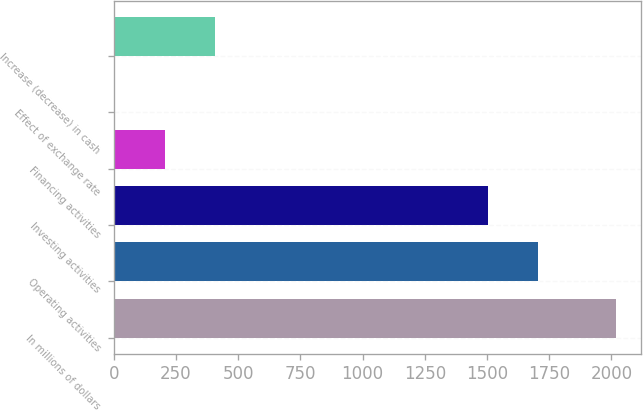<chart> <loc_0><loc_0><loc_500><loc_500><bar_chart><fcel>In millions of dollars<fcel>Operating activities<fcel>Investing activities<fcel>Financing activities<fcel>Effect of exchange rate<fcel>Increase (decrease) in cash<nl><fcel>2018<fcel>1704.17<fcel>1502.9<fcel>206.57<fcel>5.3<fcel>407.84<nl></chart> 